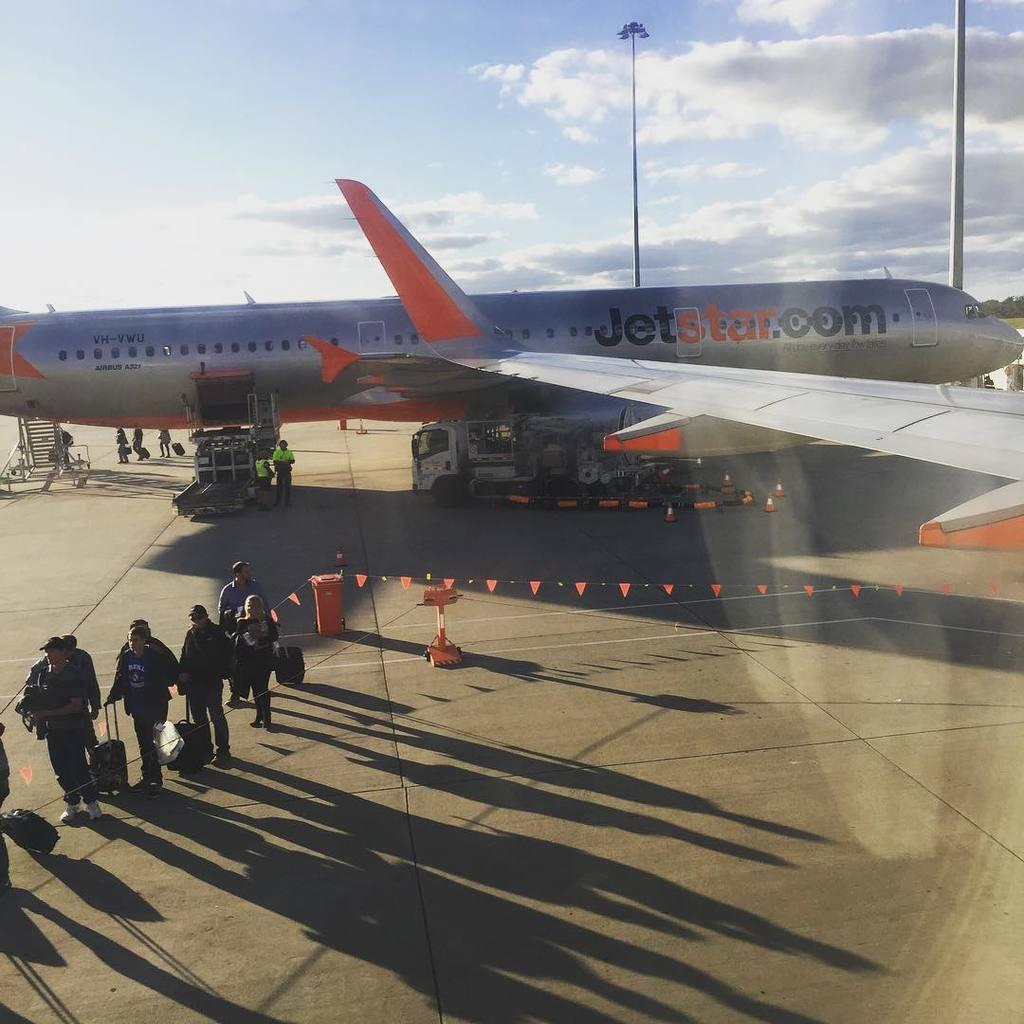<image>
Write a terse but informative summary of the picture. People carry their luggage from a Jet Star plane. 